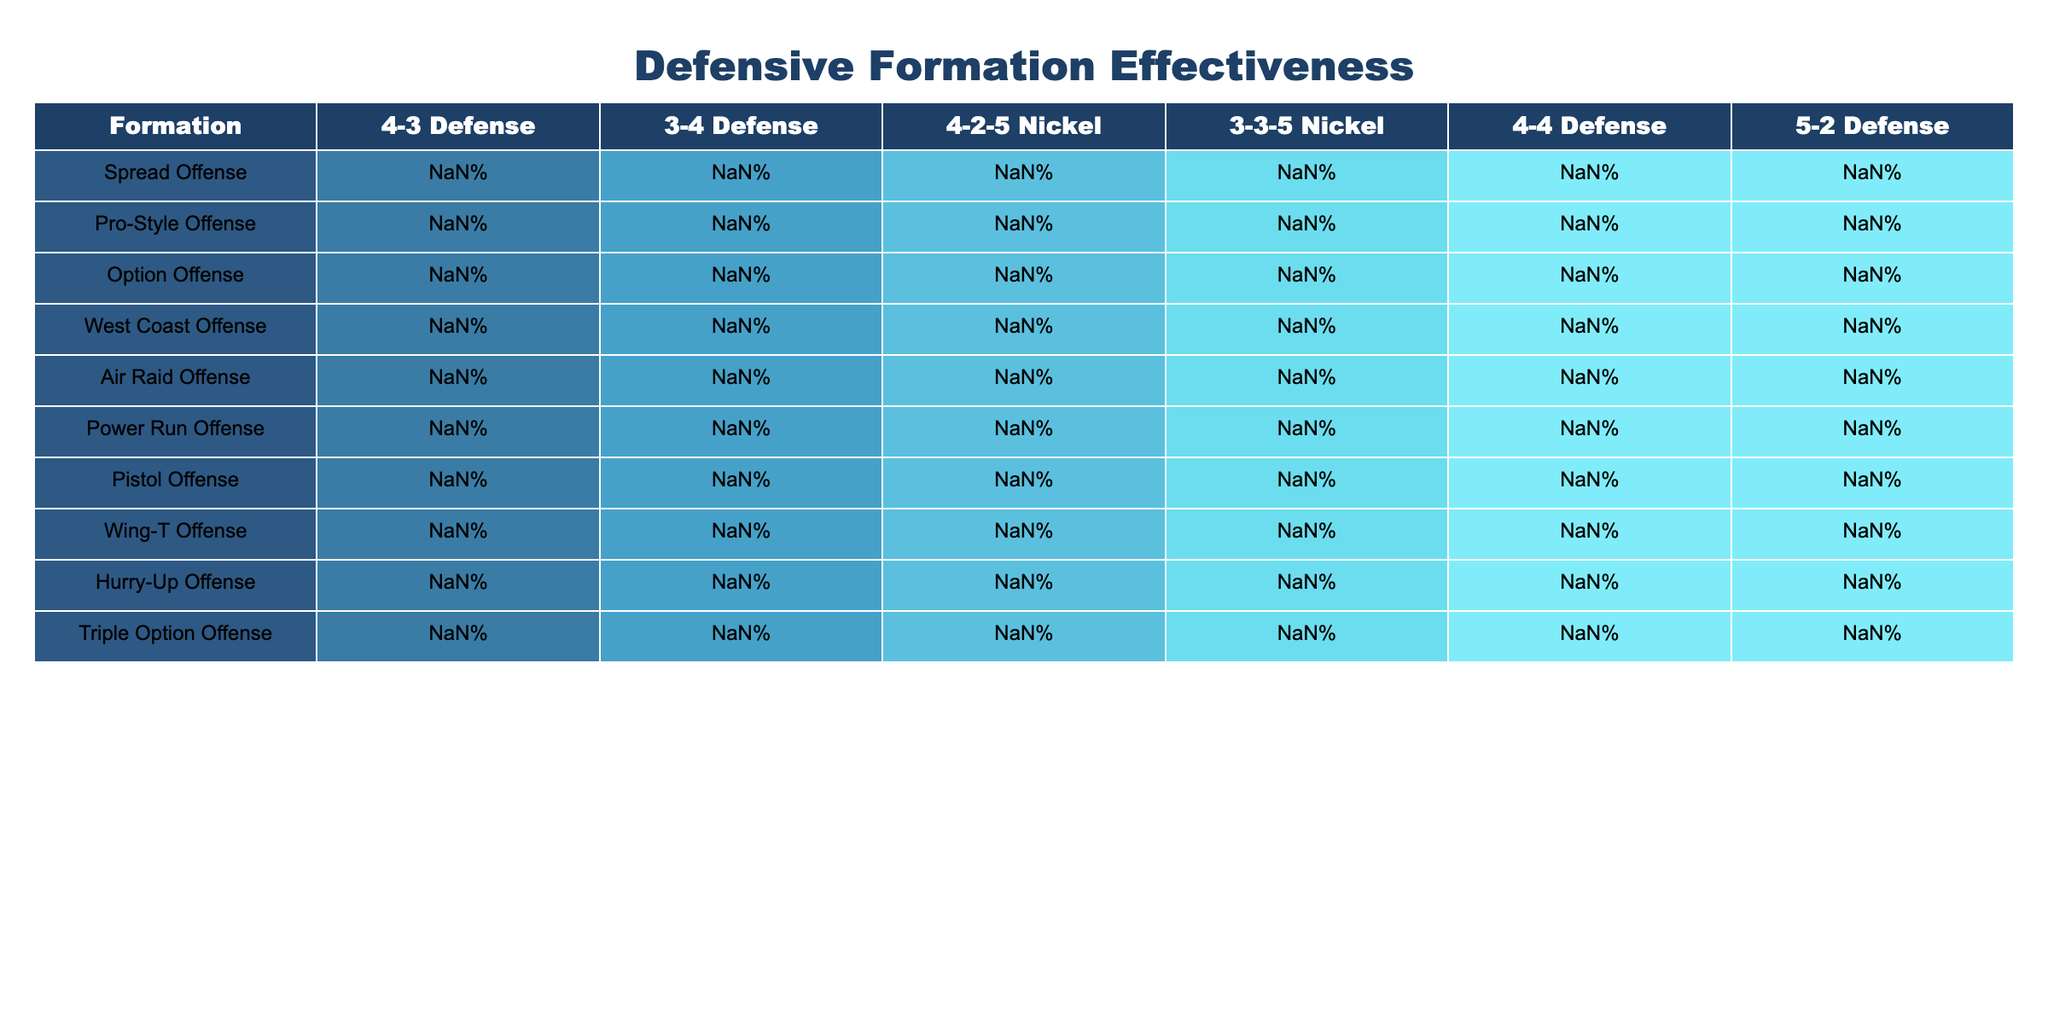What is the effectiveness percentage of the 4-3 Defense against the Spread Offense? According to the table, the effectiveness percentage of the 4-3 Defense against the Spread Offense is 65%.
Answer: 65% Which defensive formation has the highest effectiveness against the Air Raid Offense? From the table, the 4-2-5 Nickel formation has the highest effectiveness against the Air Raid Offense at 75%.
Answer: 4-2-5 Nickel What is the difference in effectiveness between the 3-4 Defense and 4-4 Defense against the Power Run Offense? The effectiveness of the 3-4 Defense against the Power Run Offense is 72%, while the 4-4 Defense is 78%. The difference is 78% - 72% = 6%.
Answer: 6% Which offensive strategy is least effectively defended by the 5-2 Defense? By examining the table, the 5-2 Defense is least effective against the Air Raid Offense, with an effectiveness of 52%.
Answer: Air Raid Offense What is the average effectiveness of the 4-3 Defense across all offensive strategies? The effectiveness percentages for the 4-3 Defense are 65%, 72%, 60%, 68%, 62%, 75%, 64%, 70%, 58%, and 62%. The average is calculated as follows: (65 + 72 + 60 + 68 + 62 + 75 + 64 + 70 + 58 + 62) / 10 = 66.2%.
Answer: 66.2% Is the effectiveness of the 3-3-5 Nickel against the Hurry-Up Offense higher than that against the Option Offense? The effectiveness of the 3-3-5 Nickel against the Hurry-Up Offense is 76%, while against the Option Offense is 62%. Since 76% > 62%, the statement is true.
Answer: Yes What is the effectiveness of the Wing-T Offense against the 5-2 Defense? The table shows that the effectiveness of the Wing-T Offense against the 5-2 Defense is 75%.
Answer: 75% Which two formations have the same effectiveness against the Option Offense? Upon reviewing the data, both the 4-4 Defense and 5-2 Defense have an effectiveness of 70% against the Option Offense.
Answer: 4-4 Defense and 5-2 Defense If we compare the effectiveness of the 4-3 Defense and the 3-4 Defense against the Pro-Style Offense, which one is more effective? The 4-3 Defense has an effectiveness of 72%, while the 3-4 Defense stands at 68%. Thus, the 4-3 Defense is more effective.
Answer: 4-3 Defense Which defensive formation is the least effective overall against the various offesive strategies? By looking closely at the lowest effectiveness percentages across all offensives, the 5-2 Defense has the least effectiveness overall, particularly against the Air Raid Offense at 52%.
Answer: 5-2 Defense 